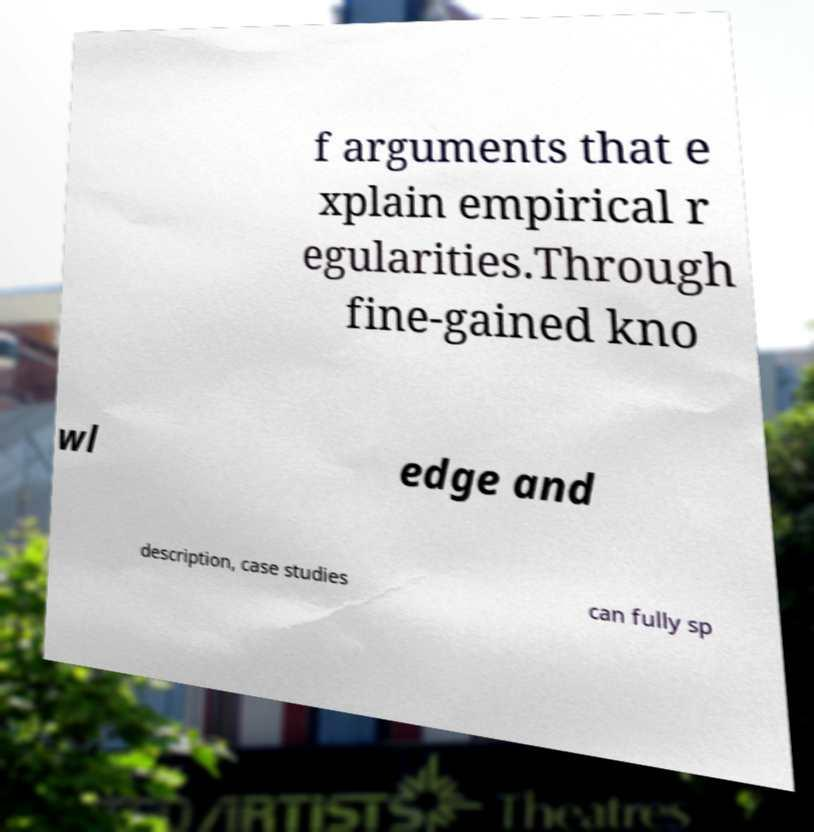There's text embedded in this image that I need extracted. Can you transcribe it verbatim? f arguments that e xplain empirical r egularities.Through fine-gained kno wl edge and description, case studies can fully sp 